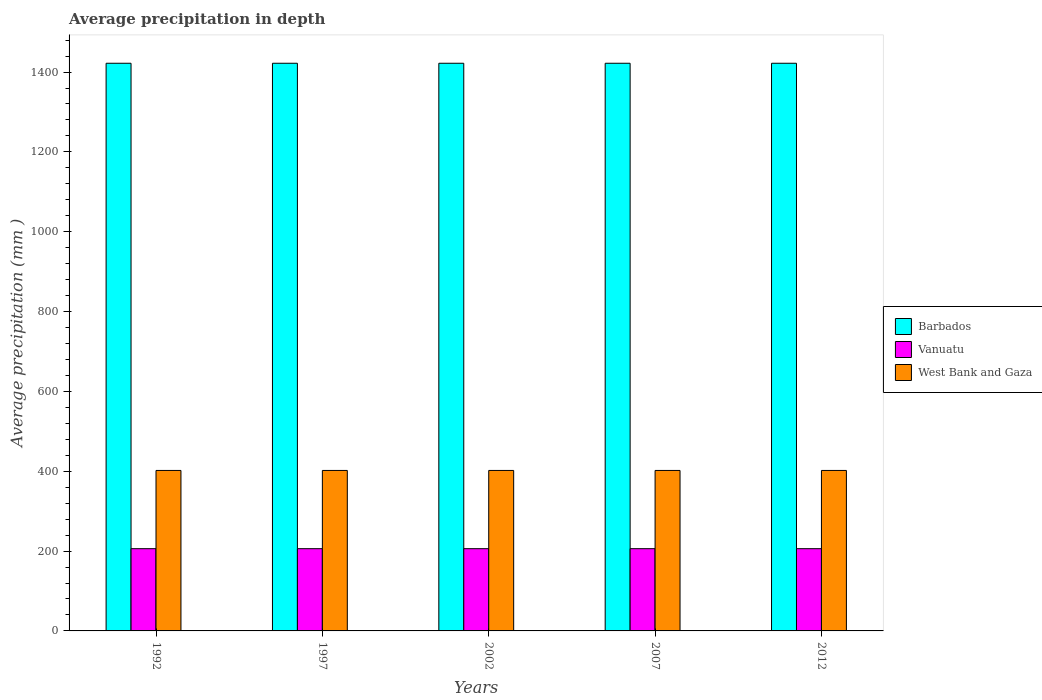Are the number of bars per tick equal to the number of legend labels?
Offer a very short reply. Yes. Are the number of bars on each tick of the X-axis equal?
Give a very brief answer. Yes. How many bars are there on the 2nd tick from the left?
Offer a terse response. 3. How many bars are there on the 2nd tick from the right?
Provide a short and direct response. 3. What is the label of the 4th group of bars from the left?
Your answer should be compact. 2007. What is the average precipitation in Vanuatu in 2012?
Your answer should be very brief. 206. Across all years, what is the maximum average precipitation in Vanuatu?
Give a very brief answer. 206. Across all years, what is the minimum average precipitation in Vanuatu?
Ensure brevity in your answer.  206. In which year was the average precipitation in Vanuatu maximum?
Ensure brevity in your answer.  1992. What is the total average precipitation in Barbados in the graph?
Your answer should be very brief. 7110. What is the difference between the average precipitation in Vanuatu in 1992 and that in 2012?
Give a very brief answer. 0. What is the difference between the average precipitation in Vanuatu in 2007 and the average precipitation in Barbados in 2012?
Your answer should be compact. -1216. What is the average average precipitation in Vanuatu per year?
Ensure brevity in your answer.  206. In the year 2002, what is the difference between the average precipitation in West Bank and Gaza and average precipitation in Vanuatu?
Offer a very short reply. 196. What is the ratio of the average precipitation in West Bank and Gaza in 1992 to that in 2012?
Your response must be concise. 1. Is the difference between the average precipitation in West Bank and Gaza in 1992 and 2007 greater than the difference between the average precipitation in Vanuatu in 1992 and 2007?
Offer a very short reply. No. Is the sum of the average precipitation in Barbados in 1997 and 2007 greater than the maximum average precipitation in West Bank and Gaza across all years?
Give a very brief answer. Yes. What does the 2nd bar from the left in 2002 represents?
Offer a very short reply. Vanuatu. What does the 2nd bar from the right in 2012 represents?
Offer a very short reply. Vanuatu. Are all the bars in the graph horizontal?
Your answer should be very brief. No. How many years are there in the graph?
Provide a short and direct response. 5. What is the difference between two consecutive major ticks on the Y-axis?
Your answer should be very brief. 200. Are the values on the major ticks of Y-axis written in scientific E-notation?
Offer a very short reply. No. What is the title of the graph?
Your answer should be very brief. Average precipitation in depth. What is the label or title of the X-axis?
Offer a terse response. Years. What is the label or title of the Y-axis?
Ensure brevity in your answer.  Average precipitation (mm ). What is the Average precipitation (mm ) in Barbados in 1992?
Your response must be concise. 1422. What is the Average precipitation (mm ) in Vanuatu in 1992?
Offer a very short reply. 206. What is the Average precipitation (mm ) of West Bank and Gaza in 1992?
Your response must be concise. 402. What is the Average precipitation (mm ) of Barbados in 1997?
Give a very brief answer. 1422. What is the Average precipitation (mm ) of Vanuatu in 1997?
Make the answer very short. 206. What is the Average precipitation (mm ) of West Bank and Gaza in 1997?
Offer a terse response. 402. What is the Average precipitation (mm ) of Barbados in 2002?
Ensure brevity in your answer.  1422. What is the Average precipitation (mm ) of Vanuatu in 2002?
Keep it short and to the point. 206. What is the Average precipitation (mm ) in West Bank and Gaza in 2002?
Keep it short and to the point. 402. What is the Average precipitation (mm ) in Barbados in 2007?
Make the answer very short. 1422. What is the Average precipitation (mm ) of Vanuatu in 2007?
Provide a short and direct response. 206. What is the Average precipitation (mm ) of West Bank and Gaza in 2007?
Offer a terse response. 402. What is the Average precipitation (mm ) in Barbados in 2012?
Ensure brevity in your answer.  1422. What is the Average precipitation (mm ) in Vanuatu in 2012?
Your answer should be very brief. 206. What is the Average precipitation (mm ) in West Bank and Gaza in 2012?
Give a very brief answer. 402. Across all years, what is the maximum Average precipitation (mm ) in Barbados?
Give a very brief answer. 1422. Across all years, what is the maximum Average precipitation (mm ) of Vanuatu?
Your answer should be compact. 206. Across all years, what is the maximum Average precipitation (mm ) in West Bank and Gaza?
Ensure brevity in your answer.  402. Across all years, what is the minimum Average precipitation (mm ) in Barbados?
Your response must be concise. 1422. Across all years, what is the minimum Average precipitation (mm ) of Vanuatu?
Ensure brevity in your answer.  206. Across all years, what is the minimum Average precipitation (mm ) of West Bank and Gaza?
Offer a terse response. 402. What is the total Average precipitation (mm ) of Barbados in the graph?
Give a very brief answer. 7110. What is the total Average precipitation (mm ) of Vanuatu in the graph?
Ensure brevity in your answer.  1030. What is the total Average precipitation (mm ) in West Bank and Gaza in the graph?
Offer a terse response. 2010. What is the difference between the Average precipitation (mm ) of Barbados in 1992 and that in 1997?
Your response must be concise. 0. What is the difference between the Average precipitation (mm ) in Vanuatu in 1992 and that in 1997?
Ensure brevity in your answer.  0. What is the difference between the Average precipitation (mm ) in Barbados in 1992 and that in 2012?
Your answer should be compact. 0. What is the difference between the Average precipitation (mm ) of West Bank and Gaza in 1997 and that in 2002?
Keep it short and to the point. 0. What is the difference between the Average precipitation (mm ) of Barbados in 1997 and that in 2007?
Make the answer very short. 0. What is the difference between the Average precipitation (mm ) in Vanuatu in 1997 and that in 2012?
Ensure brevity in your answer.  0. What is the difference between the Average precipitation (mm ) in West Bank and Gaza in 1997 and that in 2012?
Your answer should be compact. 0. What is the difference between the Average precipitation (mm ) in Barbados in 2002 and that in 2007?
Give a very brief answer. 0. What is the difference between the Average precipitation (mm ) of Vanuatu in 2002 and that in 2007?
Your response must be concise. 0. What is the difference between the Average precipitation (mm ) in West Bank and Gaza in 2002 and that in 2007?
Your response must be concise. 0. What is the difference between the Average precipitation (mm ) in Vanuatu in 2002 and that in 2012?
Offer a very short reply. 0. What is the difference between the Average precipitation (mm ) in West Bank and Gaza in 2002 and that in 2012?
Keep it short and to the point. 0. What is the difference between the Average precipitation (mm ) of Vanuatu in 2007 and that in 2012?
Your response must be concise. 0. What is the difference between the Average precipitation (mm ) of West Bank and Gaza in 2007 and that in 2012?
Your answer should be compact. 0. What is the difference between the Average precipitation (mm ) in Barbados in 1992 and the Average precipitation (mm ) in Vanuatu in 1997?
Give a very brief answer. 1216. What is the difference between the Average precipitation (mm ) in Barbados in 1992 and the Average precipitation (mm ) in West Bank and Gaza in 1997?
Your answer should be compact. 1020. What is the difference between the Average precipitation (mm ) in Vanuatu in 1992 and the Average precipitation (mm ) in West Bank and Gaza in 1997?
Offer a very short reply. -196. What is the difference between the Average precipitation (mm ) of Barbados in 1992 and the Average precipitation (mm ) of Vanuatu in 2002?
Your answer should be very brief. 1216. What is the difference between the Average precipitation (mm ) in Barbados in 1992 and the Average precipitation (mm ) in West Bank and Gaza in 2002?
Your answer should be very brief. 1020. What is the difference between the Average precipitation (mm ) of Vanuatu in 1992 and the Average precipitation (mm ) of West Bank and Gaza in 2002?
Your answer should be very brief. -196. What is the difference between the Average precipitation (mm ) of Barbados in 1992 and the Average precipitation (mm ) of Vanuatu in 2007?
Make the answer very short. 1216. What is the difference between the Average precipitation (mm ) of Barbados in 1992 and the Average precipitation (mm ) of West Bank and Gaza in 2007?
Your answer should be very brief. 1020. What is the difference between the Average precipitation (mm ) of Vanuatu in 1992 and the Average precipitation (mm ) of West Bank and Gaza in 2007?
Your response must be concise. -196. What is the difference between the Average precipitation (mm ) of Barbados in 1992 and the Average precipitation (mm ) of Vanuatu in 2012?
Offer a very short reply. 1216. What is the difference between the Average precipitation (mm ) of Barbados in 1992 and the Average precipitation (mm ) of West Bank and Gaza in 2012?
Provide a succinct answer. 1020. What is the difference between the Average precipitation (mm ) in Vanuatu in 1992 and the Average precipitation (mm ) in West Bank and Gaza in 2012?
Offer a very short reply. -196. What is the difference between the Average precipitation (mm ) in Barbados in 1997 and the Average precipitation (mm ) in Vanuatu in 2002?
Offer a terse response. 1216. What is the difference between the Average precipitation (mm ) of Barbados in 1997 and the Average precipitation (mm ) of West Bank and Gaza in 2002?
Offer a very short reply. 1020. What is the difference between the Average precipitation (mm ) of Vanuatu in 1997 and the Average precipitation (mm ) of West Bank and Gaza in 2002?
Provide a succinct answer. -196. What is the difference between the Average precipitation (mm ) in Barbados in 1997 and the Average precipitation (mm ) in Vanuatu in 2007?
Ensure brevity in your answer.  1216. What is the difference between the Average precipitation (mm ) in Barbados in 1997 and the Average precipitation (mm ) in West Bank and Gaza in 2007?
Offer a very short reply. 1020. What is the difference between the Average precipitation (mm ) in Vanuatu in 1997 and the Average precipitation (mm ) in West Bank and Gaza in 2007?
Make the answer very short. -196. What is the difference between the Average precipitation (mm ) in Barbados in 1997 and the Average precipitation (mm ) in Vanuatu in 2012?
Keep it short and to the point. 1216. What is the difference between the Average precipitation (mm ) of Barbados in 1997 and the Average precipitation (mm ) of West Bank and Gaza in 2012?
Make the answer very short. 1020. What is the difference between the Average precipitation (mm ) in Vanuatu in 1997 and the Average precipitation (mm ) in West Bank and Gaza in 2012?
Ensure brevity in your answer.  -196. What is the difference between the Average precipitation (mm ) of Barbados in 2002 and the Average precipitation (mm ) of Vanuatu in 2007?
Give a very brief answer. 1216. What is the difference between the Average precipitation (mm ) of Barbados in 2002 and the Average precipitation (mm ) of West Bank and Gaza in 2007?
Offer a terse response. 1020. What is the difference between the Average precipitation (mm ) of Vanuatu in 2002 and the Average precipitation (mm ) of West Bank and Gaza in 2007?
Provide a succinct answer. -196. What is the difference between the Average precipitation (mm ) in Barbados in 2002 and the Average precipitation (mm ) in Vanuatu in 2012?
Your answer should be compact. 1216. What is the difference between the Average precipitation (mm ) in Barbados in 2002 and the Average precipitation (mm ) in West Bank and Gaza in 2012?
Provide a short and direct response. 1020. What is the difference between the Average precipitation (mm ) of Vanuatu in 2002 and the Average precipitation (mm ) of West Bank and Gaza in 2012?
Give a very brief answer. -196. What is the difference between the Average precipitation (mm ) in Barbados in 2007 and the Average precipitation (mm ) in Vanuatu in 2012?
Give a very brief answer. 1216. What is the difference between the Average precipitation (mm ) of Barbados in 2007 and the Average precipitation (mm ) of West Bank and Gaza in 2012?
Keep it short and to the point. 1020. What is the difference between the Average precipitation (mm ) in Vanuatu in 2007 and the Average precipitation (mm ) in West Bank and Gaza in 2012?
Provide a succinct answer. -196. What is the average Average precipitation (mm ) in Barbados per year?
Your answer should be very brief. 1422. What is the average Average precipitation (mm ) of Vanuatu per year?
Your response must be concise. 206. What is the average Average precipitation (mm ) in West Bank and Gaza per year?
Give a very brief answer. 402. In the year 1992, what is the difference between the Average precipitation (mm ) in Barbados and Average precipitation (mm ) in Vanuatu?
Make the answer very short. 1216. In the year 1992, what is the difference between the Average precipitation (mm ) in Barbados and Average precipitation (mm ) in West Bank and Gaza?
Provide a succinct answer. 1020. In the year 1992, what is the difference between the Average precipitation (mm ) of Vanuatu and Average precipitation (mm ) of West Bank and Gaza?
Provide a short and direct response. -196. In the year 1997, what is the difference between the Average precipitation (mm ) of Barbados and Average precipitation (mm ) of Vanuatu?
Provide a succinct answer. 1216. In the year 1997, what is the difference between the Average precipitation (mm ) in Barbados and Average precipitation (mm ) in West Bank and Gaza?
Offer a terse response. 1020. In the year 1997, what is the difference between the Average precipitation (mm ) of Vanuatu and Average precipitation (mm ) of West Bank and Gaza?
Offer a terse response. -196. In the year 2002, what is the difference between the Average precipitation (mm ) of Barbados and Average precipitation (mm ) of Vanuatu?
Your answer should be compact. 1216. In the year 2002, what is the difference between the Average precipitation (mm ) of Barbados and Average precipitation (mm ) of West Bank and Gaza?
Ensure brevity in your answer.  1020. In the year 2002, what is the difference between the Average precipitation (mm ) in Vanuatu and Average precipitation (mm ) in West Bank and Gaza?
Give a very brief answer. -196. In the year 2007, what is the difference between the Average precipitation (mm ) in Barbados and Average precipitation (mm ) in Vanuatu?
Keep it short and to the point. 1216. In the year 2007, what is the difference between the Average precipitation (mm ) in Barbados and Average precipitation (mm ) in West Bank and Gaza?
Offer a terse response. 1020. In the year 2007, what is the difference between the Average precipitation (mm ) in Vanuatu and Average precipitation (mm ) in West Bank and Gaza?
Provide a succinct answer. -196. In the year 2012, what is the difference between the Average precipitation (mm ) of Barbados and Average precipitation (mm ) of Vanuatu?
Offer a very short reply. 1216. In the year 2012, what is the difference between the Average precipitation (mm ) of Barbados and Average precipitation (mm ) of West Bank and Gaza?
Provide a succinct answer. 1020. In the year 2012, what is the difference between the Average precipitation (mm ) of Vanuatu and Average precipitation (mm ) of West Bank and Gaza?
Your answer should be compact. -196. What is the ratio of the Average precipitation (mm ) in Barbados in 1992 to that in 1997?
Ensure brevity in your answer.  1. What is the ratio of the Average precipitation (mm ) of Barbados in 1992 to that in 2002?
Ensure brevity in your answer.  1. What is the ratio of the Average precipitation (mm ) of Vanuatu in 1992 to that in 2002?
Provide a short and direct response. 1. What is the ratio of the Average precipitation (mm ) of Barbados in 1992 to that in 2007?
Offer a terse response. 1. What is the ratio of the Average precipitation (mm ) in West Bank and Gaza in 1992 to that in 2007?
Provide a succinct answer. 1. What is the ratio of the Average precipitation (mm ) of Barbados in 1997 to that in 2002?
Ensure brevity in your answer.  1. What is the ratio of the Average precipitation (mm ) in Vanuatu in 1997 to that in 2002?
Ensure brevity in your answer.  1. What is the ratio of the Average precipitation (mm ) of West Bank and Gaza in 1997 to that in 2002?
Your answer should be compact. 1. What is the ratio of the Average precipitation (mm ) in Vanuatu in 1997 to that in 2007?
Keep it short and to the point. 1. What is the ratio of the Average precipitation (mm ) in Barbados in 1997 to that in 2012?
Your answer should be compact. 1. What is the ratio of the Average precipitation (mm ) of Vanuatu in 1997 to that in 2012?
Provide a short and direct response. 1. What is the ratio of the Average precipitation (mm ) of Barbados in 2002 to that in 2007?
Your answer should be very brief. 1. What is the ratio of the Average precipitation (mm ) in West Bank and Gaza in 2002 to that in 2007?
Give a very brief answer. 1. What is the ratio of the Average precipitation (mm ) in West Bank and Gaza in 2002 to that in 2012?
Provide a short and direct response. 1. What is the ratio of the Average precipitation (mm ) in Barbados in 2007 to that in 2012?
Keep it short and to the point. 1. What is the ratio of the Average precipitation (mm ) in West Bank and Gaza in 2007 to that in 2012?
Provide a succinct answer. 1. What is the difference between the highest and the lowest Average precipitation (mm ) of Barbados?
Give a very brief answer. 0. What is the difference between the highest and the lowest Average precipitation (mm ) of Vanuatu?
Make the answer very short. 0. 